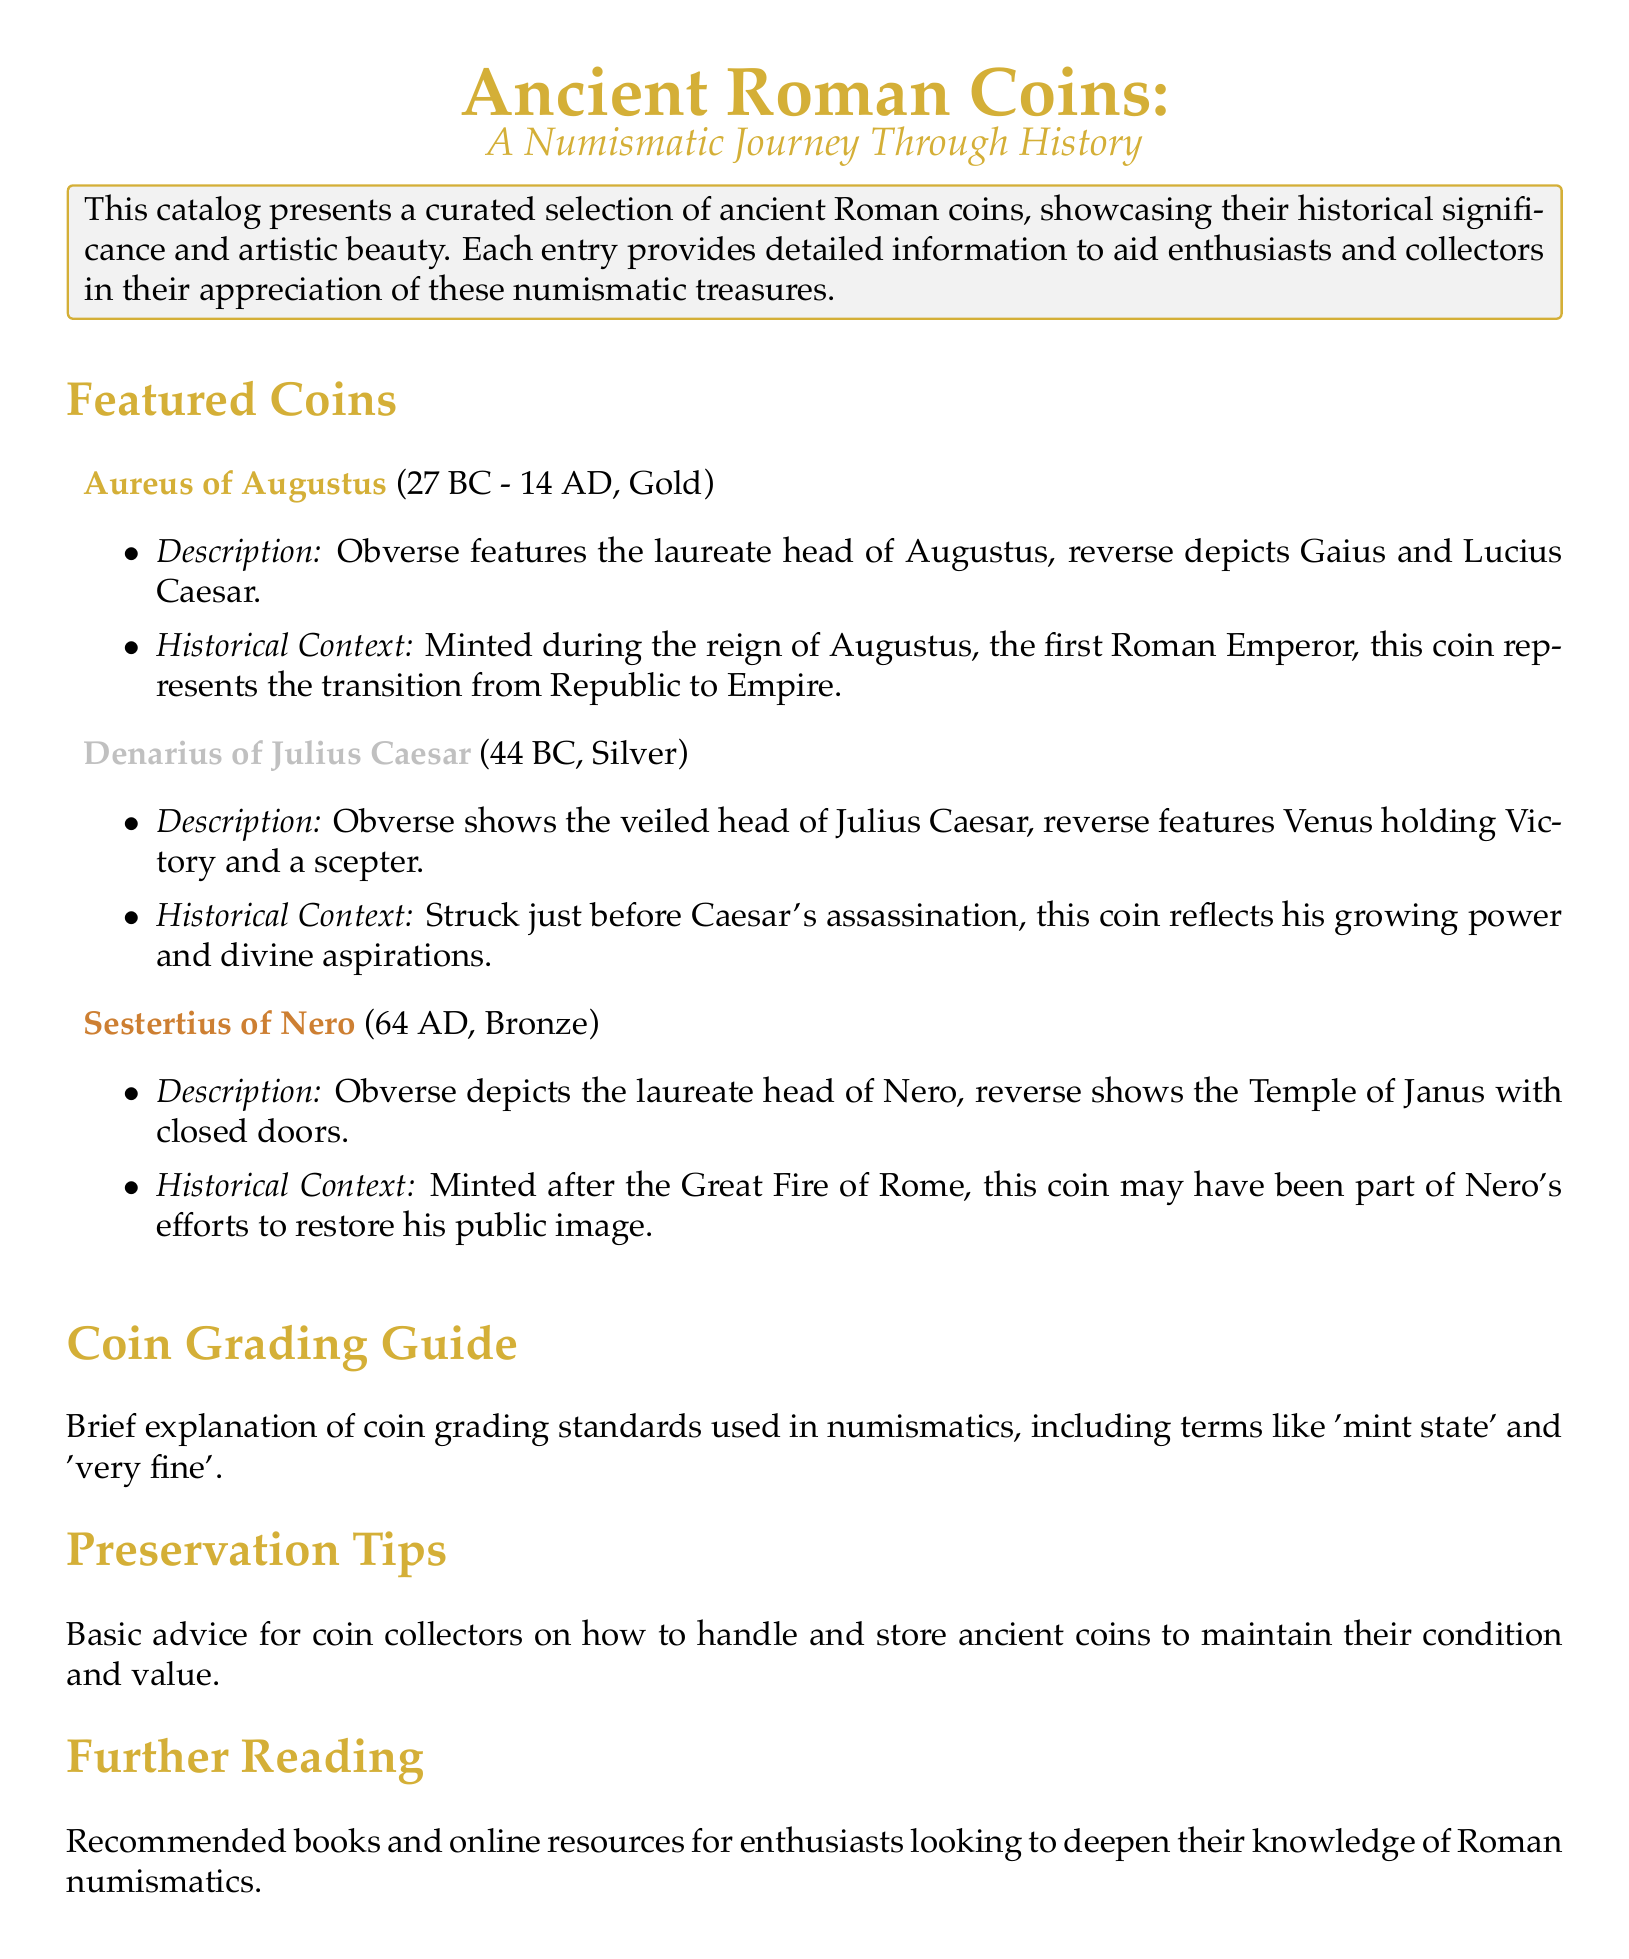What is the name of the gold coin featured in the catalog? The catalog highlights the "Aureus of Augustus" as a featured gold coin.
Answer: Aureus of Augustus What year was the Denarius of Julius Caesar minted? The Denarius of Julius Caesar was minted in 44 BC, as stated in the catalog.
Answer: 44 BC Which metal is the Sestertius of Nero made from? The Sestertius of Nero is categorized as a bronze coin, according to the description.
Answer: Bronze What does the reverse of the Aureus of Augustus depict? The reverse of the Aureus shows Gaius and Lucius Caesar, as detailed in the description.
Answer: Gaius and Lucius Caesar What historical event is associated with the Minting of the Sestertius of Nero? The Sestertius of Nero is minted after the Great Fire of Rome, as mentioned in the historical context.
Answer: Great Fire of Rome What is included in the Coin Grading Guide section? The Coin Grading Guide section provides explanations of grading standards used in numismatics.
Answer: Grading standards What kind of tips can collectors find in the Preservation Tips section? The Preservation Tips section offers basic advice on handling and storing ancient coins.
Answer: Handling and storing advice What is the primary focus of the catalog? The catalog primarily focuses on showcasing ancient Roman coins and their historical significance.
Answer: Ancient Roman coins 